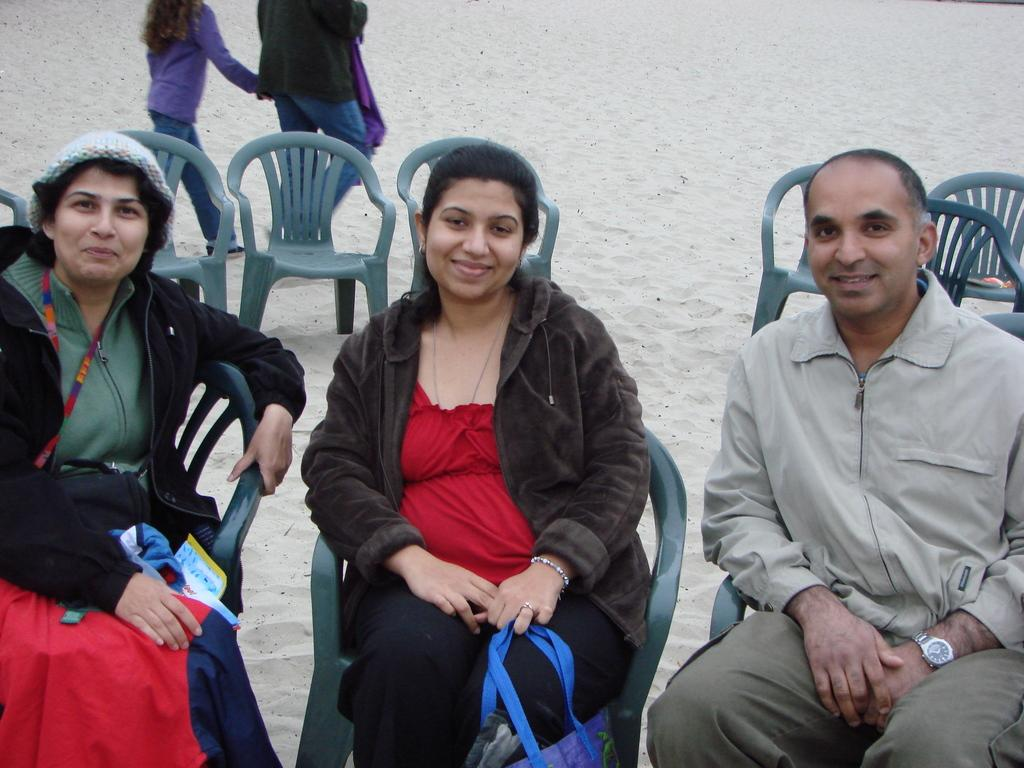How many people are present in the image? There are three people in the image. What are the people doing in the image? The people are sitting on chairs and smiling. Can you describe the woman in the image? The woman is holding a bag. What can be seen in the background of the image? There is sand visible in the background, as well as chairs and two people. What type of book is the man reading in the image? There is no book present in the image, and the people are not reading. 